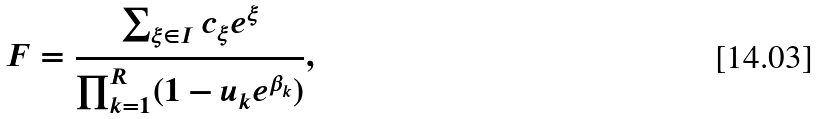Convert formula to latex. <formula><loc_0><loc_0><loc_500><loc_500>F = \frac { \sum _ { \xi \in I } c _ { \xi } e ^ { \xi } } { \prod _ { k = 1 } ^ { R } ( 1 - u _ { k } e ^ { \beta _ { k } } ) } ,</formula> 